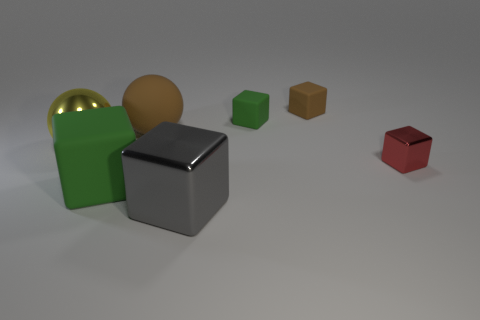What number of objects are things left of the tiny brown matte thing or brown rubber balls?
Provide a succinct answer. 5. What number of other objects are the same size as the gray metallic cube?
Keep it short and to the point. 3. What is the material of the green object behind the large rubber thing that is on the left side of the big brown matte thing that is behind the large gray block?
Offer a terse response. Rubber. How many cylinders are either tiny brown things or small shiny objects?
Offer a terse response. 0. Is the number of big green rubber objects left of the brown cube greater than the number of green cubes that are to the left of the big yellow shiny object?
Provide a short and direct response. Yes. How many tiny brown rubber blocks are to the left of the large block that is right of the large rubber cube?
Provide a succinct answer. 0. What number of things are tiny green rubber objects or small purple rubber spheres?
Offer a terse response. 1. Is the big yellow thing the same shape as the big gray object?
Your answer should be compact. No. What material is the small brown object?
Offer a terse response. Rubber. How many big objects are both in front of the big yellow sphere and behind the small shiny thing?
Offer a terse response. 0. 